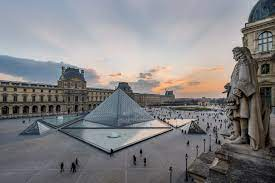What could you imagine happening in this courtyard a hundred years from now? Imagine a future where the Louvre courtyard has evolved into a cultural hub bustling with activity and innovation. Advanced technology has been seamlessly integrated into the historical site, with augmented reality displays providing immersive historical and artistic tours. The glass pyramid, now equipped with energy-efficient smart glass, changes opacity to adapt to the weather and optimize natural lighting. The reflective pool has been transformed into a dynamic art installation, featuring interactive light shows and holographic displays. Visitors from around the world still flock to the Louvre, but now they also engage in virtual reality experiences that bring to life the stories behind the masterpieces. The courtyard is alive with a blend of art, history, and technology, creating a vibrant, ever-changing space where the past and future coexist. Can you describe a realistic busy day in the Louvre's courtyard? On a typical busy day at the Louvre's courtyard, the area is teeming with activity. Tourists from around the globe gather, eagerly snapping photos of the iconic glass pyramid and the magnificent classical architecture that surrounds it. Guided tours are in full swing, with enthusiastic guides sharing fascinating anecdotes about the museum's rich history and its art collections. School groups, led by teachers, marvel at the architectural beauty and participate in educational activities. The sound of footsteps and chatter fills the air, blending with the occasional clicking of camera shutters. Street performers and artists add to the lively atmosphere, entertaining passersby with music, mimicry, and sketches. Despite the crowd, there's a sense of excitement and wonder as visitors prepare to explore the vast treasures housed within the Louvre. 